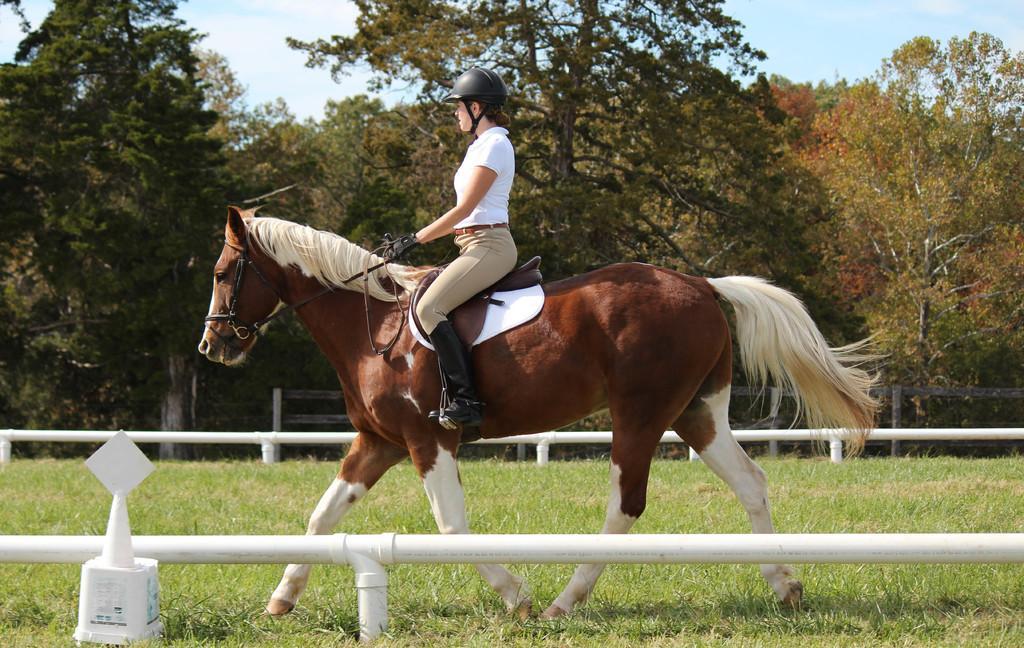Please provide a concise description of this image. In this image I can see a woman is riding a horse, I can also see she is wearing helmet and white T-shirt. In the background I can see number of trees and clear view of sky. 